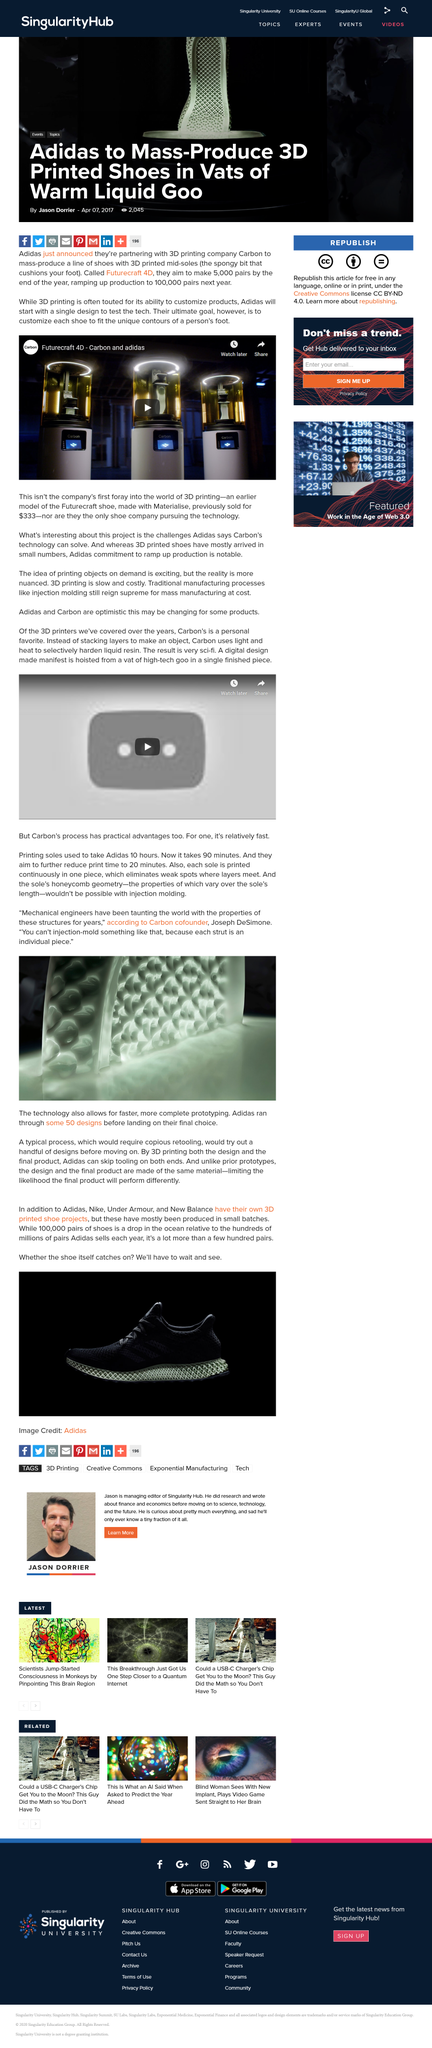Specify some key components in this picture. Adidas is partnering with the Carbon company to promote sustainability in the fashion industry. Adidas will use a single design to test its new tech. 3D printing technology enables the rapid creation of more complete and accurate prototypes, allowing for faster and more efficient product development and testing. Adidas is not the only company that has its own 3D printed shoe project, as Nike, Under Armour, and New Balance have also embarked on similar initiatives. In the depicted image, a 3D printer is visibly operating, demonstrating its efficiency and usefulness in creating three-dimensional objects. 